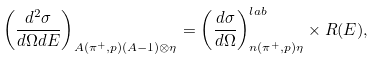<formula> <loc_0><loc_0><loc_500><loc_500>\left ( \frac { d ^ { 2 } \sigma } { d \Omega d E } \right ) _ { A ( \pi ^ { + } , p ) ( A - 1 ) \otimes \eta } = \left ( \frac { d \sigma } { d \Omega } \right ) ^ { l a b } _ { n ( \pi ^ { + } , p ) \eta } \times R ( E ) ,</formula> 